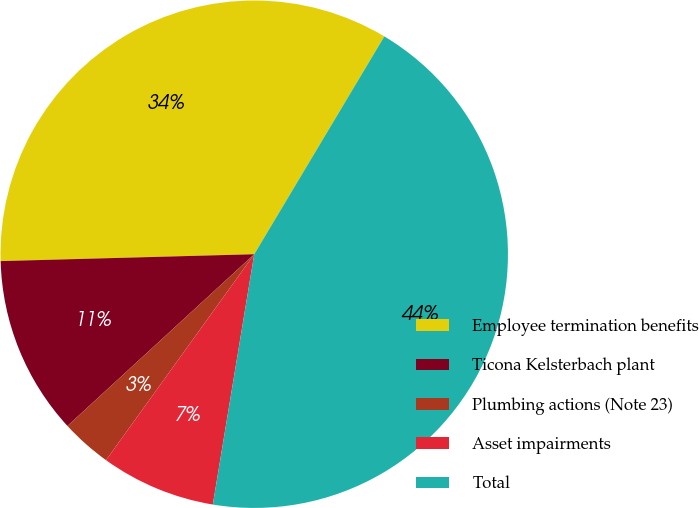Convert chart to OTSL. <chart><loc_0><loc_0><loc_500><loc_500><pie_chart><fcel>Employee termination benefits<fcel>Ticona Kelsterbach plant<fcel>Plumbing actions (Note 23)<fcel>Asset impairments<fcel>Total<nl><fcel>34.0%<fcel>11.4%<fcel>3.24%<fcel>7.32%<fcel>44.04%<nl></chart> 